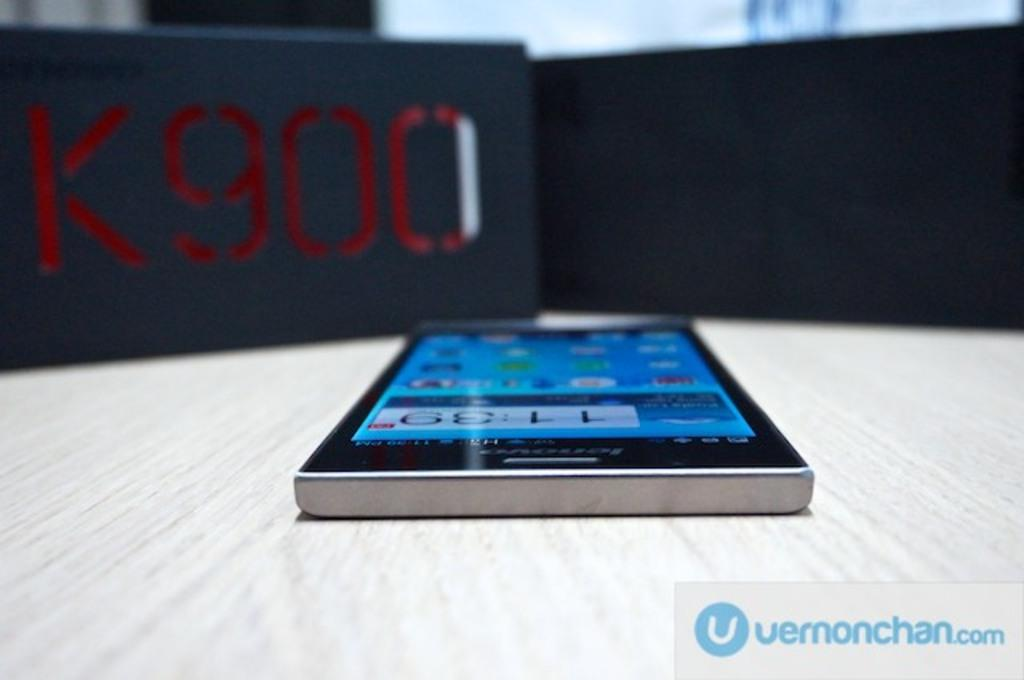Provide a one-sentence caption for the provided image. a phone near a black background that says K900. 